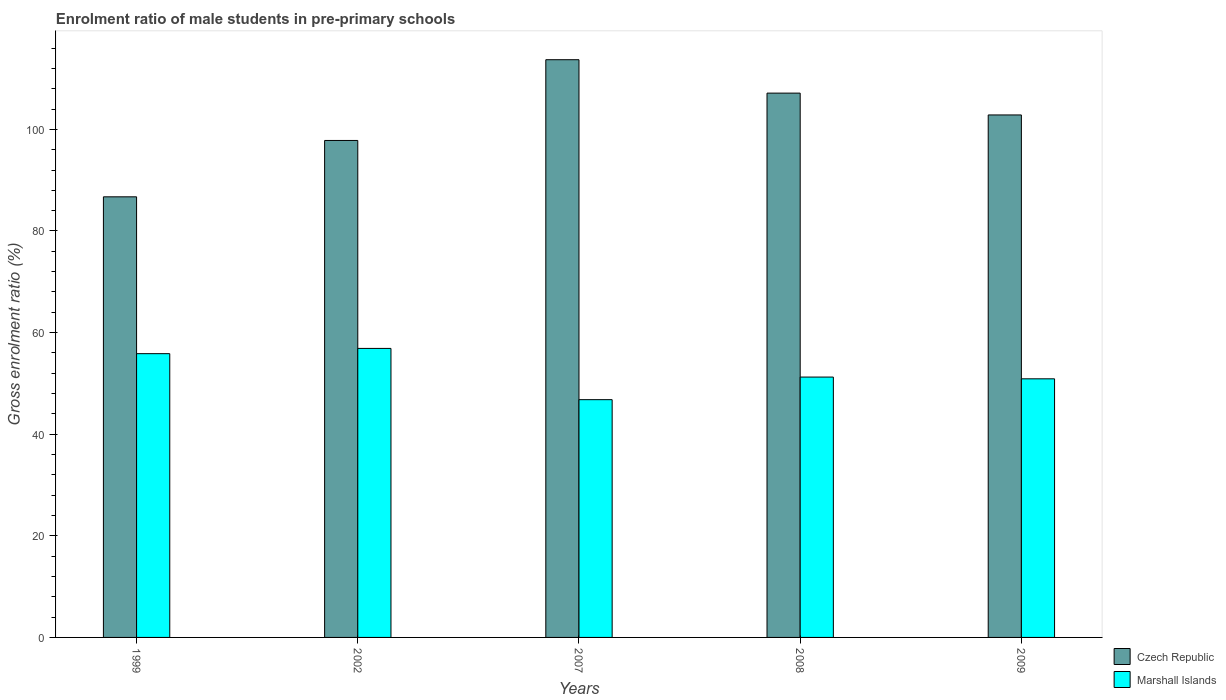How many different coloured bars are there?
Provide a short and direct response. 2. Are the number of bars per tick equal to the number of legend labels?
Keep it short and to the point. Yes. Are the number of bars on each tick of the X-axis equal?
Keep it short and to the point. Yes. How many bars are there on the 5th tick from the right?
Offer a very short reply. 2. What is the label of the 5th group of bars from the left?
Keep it short and to the point. 2009. In how many cases, is the number of bars for a given year not equal to the number of legend labels?
Provide a succinct answer. 0. What is the enrolment ratio of male students in pre-primary schools in Marshall Islands in 2008?
Your answer should be very brief. 51.24. Across all years, what is the maximum enrolment ratio of male students in pre-primary schools in Marshall Islands?
Keep it short and to the point. 56.88. Across all years, what is the minimum enrolment ratio of male students in pre-primary schools in Czech Republic?
Provide a short and direct response. 86.72. In which year was the enrolment ratio of male students in pre-primary schools in Czech Republic maximum?
Your answer should be compact. 2007. What is the total enrolment ratio of male students in pre-primary schools in Czech Republic in the graph?
Your response must be concise. 508.22. What is the difference between the enrolment ratio of male students in pre-primary schools in Marshall Islands in 2002 and that in 2007?
Your answer should be very brief. 10.09. What is the difference between the enrolment ratio of male students in pre-primary schools in Czech Republic in 2008 and the enrolment ratio of male students in pre-primary schools in Marshall Islands in 2007?
Your answer should be compact. 60.34. What is the average enrolment ratio of male students in pre-primary schools in Marshall Islands per year?
Offer a very short reply. 52.34. In the year 2007, what is the difference between the enrolment ratio of male students in pre-primary schools in Czech Republic and enrolment ratio of male students in pre-primary schools in Marshall Islands?
Provide a short and direct response. 66.91. In how many years, is the enrolment ratio of male students in pre-primary schools in Czech Republic greater than 28 %?
Offer a terse response. 5. What is the ratio of the enrolment ratio of male students in pre-primary schools in Marshall Islands in 2007 to that in 2008?
Keep it short and to the point. 0.91. Is the enrolment ratio of male students in pre-primary schools in Czech Republic in 2002 less than that in 2007?
Provide a succinct answer. Yes. What is the difference between the highest and the second highest enrolment ratio of male students in pre-primary schools in Marshall Islands?
Provide a short and direct response. 1.03. What is the difference between the highest and the lowest enrolment ratio of male students in pre-primary schools in Czech Republic?
Provide a short and direct response. 26.99. In how many years, is the enrolment ratio of male students in pre-primary schools in Marshall Islands greater than the average enrolment ratio of male students in pre-primary schools in Marshall Islands taken over all years?
Your answer should be very brief. 2. Is the sum of the enrolment ratio of male students in pre-primary schools in Czech Republic in 1999 and 2009 greater than the maximum enrolment ratio of male students in pre-primary schools in Marshall Islands across all years?
Your answer should be very brief. Yes. What does the 2nd bar from the left in 1999 represents?
Offer a terse response. Marshall Islands. What does the 2nd bar from the right in 2009 represents?
Your answer should be very brief. Czech Republic. How many bars are there?
Your answer should be compact. 10. How many years are there in the graph?
Ensure brevity in your answer.  5. What is the difference between two consecutive major ticks on the Y-axis?
Ensure brevity in your answer.  20. Does the graph contain any zero values?
Keep it short and to the point. No. Where does the legend appear in the graph?
Offer a terse response. Bottom right. How many legend labels are there?
Your answer should be very brief. 2. What is the title of the graph?
Offer a terse response. Enrolment ratio of male students in pre-primary schools. Does "Slovak Republic" appear as one of the legend labels in the graph?
Offer a terse response. No. What is the label or title of the Y-axis?
Ensure brevity in your answer.  Gross enrolment ratio (%). What is the Gross enrolment ratio (%) in Czech Republic in 1999?
Make the answer very short. 86.72. What is the Gross enrolment ratio (%) in Marshall Islands in 1999?
Ensure brevity in your answer.  55.85. What is the Gross enrolment ratio (%) of Czech Republic in 2002?
Your answer should be compact. 97.82. What is the Gross enrolment ratio (%) of Marshall Islands in 2002?
Your response must be concise. 56.88. What is the Gross enrolment ratio (%) of Czech Republic in 2007?
Provide a succinct answer. 113.71. What is the Gross enrolment ratio (%) in Marshall Islands in 2007?
Give a very brief answer. 46.8. What is the Gross enrolment ratio (%) in Czech Republic in 2008?
Provide a short and direct response. 107.13. What is the Gross enrolment ratio (%) in Marshall Islands in 2008?
Give a very brief answer. 51.24. What is the Gross enrolment ratio (%) in Czech Republic in 2009?
Give a very brief answer. 102.84. What is the Gross enrolment ratio (%) of Marshall Islands in 2009?
Offer a very short reply. 50.9. Across all years, what is the maximum Gross enrolment ratio (%) in Czech Republic?
Make the answer very short. 113.71. Across all years, what is the maximum Gross enrolment ratio (%) of Marshall Islands?
Offer a terse response. 56.88. Across all years, what is the minimum Gross enrolment ratio (%) of Czech Republic?
Offer a very short reply. 86.72. Across all years, what is the minimum Gross enrolment ratio (%) of Marshall Islands?
Offer a very short reply. 46.8. What is the total Gross enrolment ratio (%) of Czech Republic in the graph?
Your answer should be compact. 508.22. What is the total Gross enrolment ratio (%) of Marshall Islands in the graph?
Make the answer very short. 261.68. What is the difference between the Gross enrolment ratio (%) of Czech Republic in 1999 and that in 2002?
Provide a succinct answer. -11.09. What is the difference between the Gross enrolment ratio (%) of Marshall Islands in 1999 and that in 2002?
Ensure brevity in your answer.  -1.03. What is the difference between the Gross enrolment ratio (%) of Czech Republic in 1999 and that in 2007?
Give a very brief answer. -26.99. What is the difference between the Gross enrolment ratio (%) in Marshall Islands in 1999 and that in 2007?
Provide a short and direct response. 9.05. What is the difference between the Gross enrolment ratio (%) of Czech Republic in 1999 and that in 2008?
Give a very brief answer. -20.41. What is the difference between the Gross enrolment ratio (%) of Marshall Islands in 1999 and that in 2008?
Provide a succinct answer. 4.61. What is the difference between the Gross enrolment ratio (%) in Czech Republic in 1999 and that in 2009?
Offer a terse response. -16.11. What is the difference between the Gross enrolment ratio (%) in Marshall Islands in 1999 and that in 2009?
Ensure brevity in your answer.  4.95. What is the difference between the Gross enrolment ratio (%) of Czech Republic in 2002 and that in 2007?
Provide a short and direct response. -15.89. What is the difference between the Gross enrolment ratio (%) of Marshall Islands in 2002 and that in 2007?
Give a very brief answer. 10.09. What is the difference between the Gross enrolment ratio (%) in Czech Republic in 2002 and that in 2008?
Your response must be concise. -9.32. What is the difference between the Gross enrolment ratio (%) in Marshall Islands in 2002 and that in 2008?
Your response must be concise. 5.64. What is the difference between the Gross enrolment ratio (%) in Czech Republic in 2002 and that in 2009?
Provide a succinct answer. -5.02. What is the difference between the Gross enrolment ratio (%) of Marshall Islands in 2002 and that in 2009?
Ensure brevity in your answer.  5.98. What is the difference between the Gross enrolment ratio (%) of Czech Republic in 2007 and that in 2008?
Your answer should be very brief. 6.57. What is the difference between the Gross enrolment ratio (%) of Marshall Islands in 2007 and that in 2008?
Keep it short and to the point. -4.45. What is the difference between the Gross enrolment ratio (%) of Czech Republic in 2007 and that in 2009?
Your answer should be compact. 10.87. What is the difference between the Gross enrolment ratio (%) in Marshall Islands in 2007 and that in 2009?
Your answer should be very brief. -4.1. What is the difference between the Gross enrolment ratio (%) of Czech Republic in 2008 and that in 2009?
Your answer should be compact. 4.3. What is the difference between the Gross enrolment ratio (%) of Marshall Islands in 2008 and that in 2009?
Your answer should be compact. 0.34. What is the difference between the Gross enrolment ratio (%) in Czech Republic in 1999 and the Gross enrolment ratio (%) in Marshall Islands in 2002?
Offer a very short reply. 29.84. What is the difference between the Gross enrolment ratio (%) of Czech Republic in 1999 and the Gross enrolment ratio (%) of Marshall Islands in 2007?
Offer a very short reply. 39.93. What is the difference between the Gross enrolment ratio (%) in Czech Republic in 1999 and the Gross enrolment ratio (%) in Marshall Islands in 2008?
Give a very brief answer. 35.48. What is the difference between the Gross enrolment ratio (%) in Czech Republic in 1999 and the Gross enrolment ratio (%) in Marshall Islands in 2009?
Your answer should be compact. 35.82. What is the difference between the Gross enrolment ratio (%) of Czech Republic in 2002 and the Gross enrolment ratio (%) of Marshall Islands in 2007?
Give a very brief answer. 51.02. What is the difference between the Gross enrolment ratio (%) in Czech Republic in 2002 and the Gross enrolment ratio (%) in Marshall Islands in 2008?
Ensure brevity in your answer.  46.57. What is the difference between the Gross enrolment ratio (%) in Czech Republic in 2002 and the Gross enrolment ratio (%) in Marshall Islands in 2009?
Provide a succinct answer. 46.92. What is the difference between the Gross enrolment ratio (%) of Czech Republic in 2007 and the Gross enrolment ratio (%) of Marshall Islands in 2008?
Provide a succinct answer. 62.47. What is the difference between the Gross enrolment ratio (%) in Czech Republic in 2007 and the Gross enrolment ratio (%) in Marshall Islands in 2009?
Provide a succinct answer. 62.81. What is the difference between the Gross enrolment ratio (%) in Czech Republic in 2008 and the Gross enrolment ratio (%) in Marshall Islands in 2009?
Your answer should be very brief. 56.23. What is the average Gross enrolment ratio (%) in Czech Republic per year?
Your answer should be compact. 101.64. What is the average Gross enrolment ratio (%) in Marshall Islands per year?
Your answer should be very brief. 52.34. In the year 1999, what is the difference between the Gross enrolment ratio (%) in Czech Republic and Gross enrolment ratio (%) in Marshall Islands?
Your response must be concise. 30.87. In the year 2002, what is the difference between the Gross enrolment ratio (%) in Czech Republic and Gross enrolment ratio (%) in Marshall Islands?
Give a very brief answer. 40.93. In the year 2007, what is the difference between the Gross enrolment ratio (%) of Czech Republic and Gross enrolment ratio (%) of Marshall Islands?
Provide a short and direct response. 66.91. In the year 2008, what is the difference between the Gross enrolment ratio (%) in Czech Republic and Gross enrolment ratio (%) in Marshall Islands?
Give a very brief answer. 55.89. In the year 2009, what is the difference between the Gross enrolment ratio (%) in Czech Republic and Gross enrolment ratio (%) in Marshall Islands?
Provide a succinct answer. 51.94. What is the ratio of the Gross enrolment ratio (%) in Czech Republic in 1999 to that in 2002?
Provide a succinct answer. 0.89. What is the ratio of the Gross enrolment ratio (%) in Marshall Islands in 1999 to that in 2002?
Give a very brief answer. 0.98. What is the ratio of the Gross enrolment ratio (%) of Czech Republic in 1999 to that in 2007?
Offer a very short reply. 0.76. What is the ratio of the Gross enrolment ratio (%) in Marshall Islands in 1999 to that in 2007?
Provide a succinct answer. 1.19. What is the ratio of the Gross enrolment ratio (%) in Czech Republic in 1999 to that in 2008?
Your answer should be compact. 0.81. What is the ratio of the Gross enrolment ratio (%) of Marshall Islands in 1999 to that in 2008?
Ensure brevity in your answer.  1.09. What is the ratio of the Gross enrolment ratio (%) in Czech Republic in 1999 to that in 2009?
Give a very brief answer. 0.84. What is the ratio of the Gross enrolment ratio (%) of Marshall Islands in 1999 to that in 2009?
Provide a short and direct response. 1.1. What is the ratio of the Gross enrolment ratio (%) in Czech Republic in 2002 to that in 2007?
Ensure brevity in your answer.  0.86. What is the ratio of the Gross enrolment ratio (%) of Marshall Islands in 2002 to that in 2007?
Keep it short and to the point. 1.22. What is the ratio of the Gross enrolment ratio (%) in Czech Republic in 2002 to that in 2008?
Offer a very short reply. 0.91. What is the ratio of the Gross enrolment ratio (%) of Marshall Islands in 2002 to that in 2008?
Offer a terse response. 1.11. What is the ratio of the Gross enrolment ratio (%) in Czech Republic in 2002 to that in 2009?
Ensure brevity in your answer.  0.95. What is the ratio of the Gross enrolment ratio (%) in Marshall Islands in 2002 to that in 2009?
Keep it short and to the point. 1.12. What is the ratio of the Gross enrolment ratio (%) of Czech Republic in 2007 to that in 2008?
Provide a short and direct response. 1.06. What is the ratio of the Gross enrolment ratio (%) in Marshall Islands in 2007 to that in 2008?
Give a very brief answer. 0.91. What is the ratio of the Gross enrolment ratio (%) of Czech Republic in 2007 to that in 2009?
Give a very brief answer. 1.11. What is the ratio of the Gross enrolment ratio (%) of Marshall Islands in 2007 to that in 2009?
Offer a very short reply. 0.92. What is the ratio of the Gross enrolment ratio (%) in Czech Republic in 2008 to that in 2009?
Make the answer very short. 1.04. What is the ratio of the Gross enrolment ratio (%) in Marshall Islands in 2008 to that in 2009?
Offer a terse response. 1.01. What is the difference between the highest and the second highest Gross enrolment ratio (%) in Czech Republic?
Your answer should be very brief. 6.57. What is the difference between the highest and the second highest Gross enrolment ratio (%) in Marshall Islands?
Provide a short and direct response. 1.03. What is the difference between the highest and the lowest Gross enrolment ratio (%) of Czech Republic?
Your answer should be compact. 26.99. What is the difference between the highest and the lowest Gross enrolment ratio (%) in Marshall Islands?
Keep it short and to the point. 10.09. 